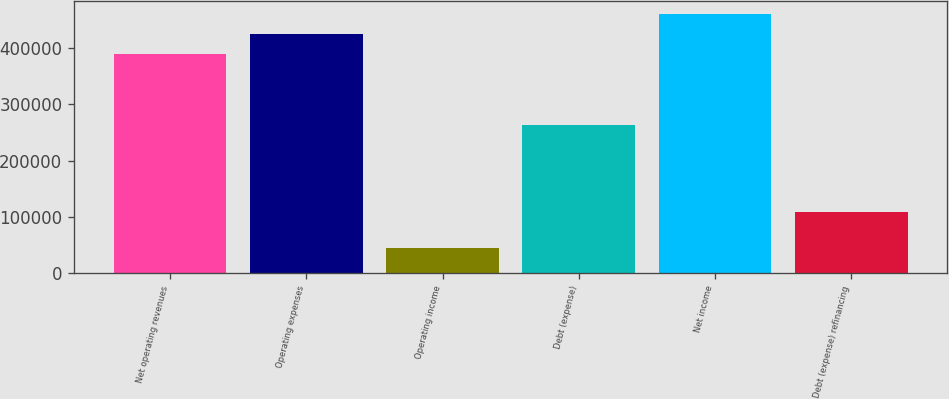Convert chart. <chart><loc_0><loc_0><loc_500><loc_500><bar_chart><fcel>Net operating revenues<fcel>Operating expenses<fcel>Operating income<fcel>Debt (expense)<fcel>Net income<fcel>Debt (expense) refinancing<nl><fcel>389893<fcel>425827<fcel>45485<fcel>262650<fcel>461760<fcel>108918<nl></chart> 